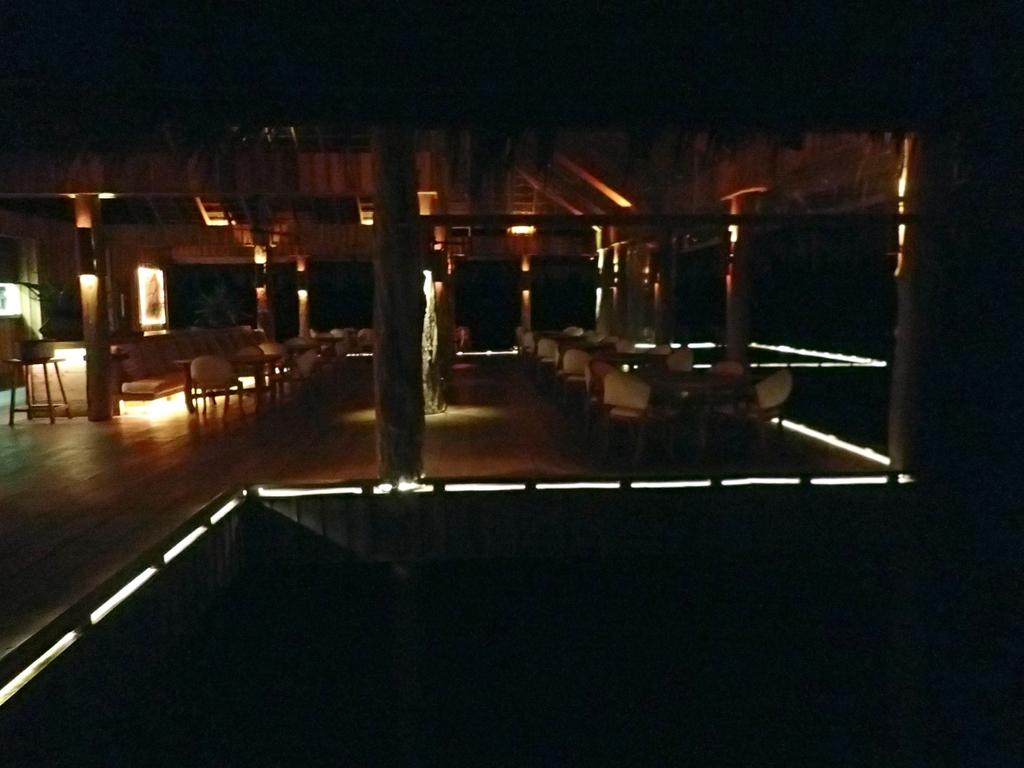What type of objects are present in the image that provide illumination? There are lights in the image. What type of furniture is visible in the image? There are chairs in the image. What architectural feature can be seen in the middle of the image? There are pillars in the middle of the image. What type of seating is located on the left side of the image? There is a stool on the left side of the image. What decision does the judge make in the image? There is no judge present in the image, so no decision can be made. What type of ghost is visible in the image? There are no ghosts present in the image. 